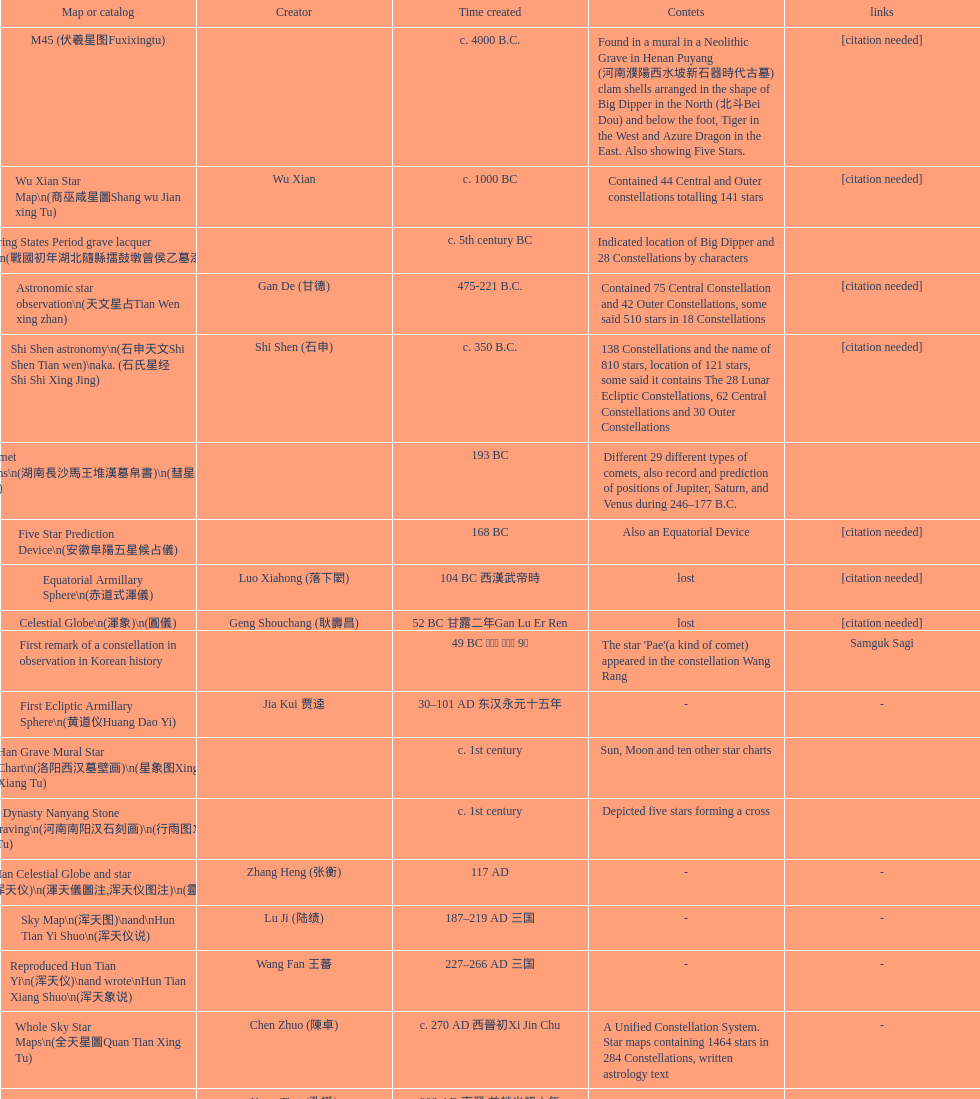When was the first map or catalog created? C. 4000 b.c. 